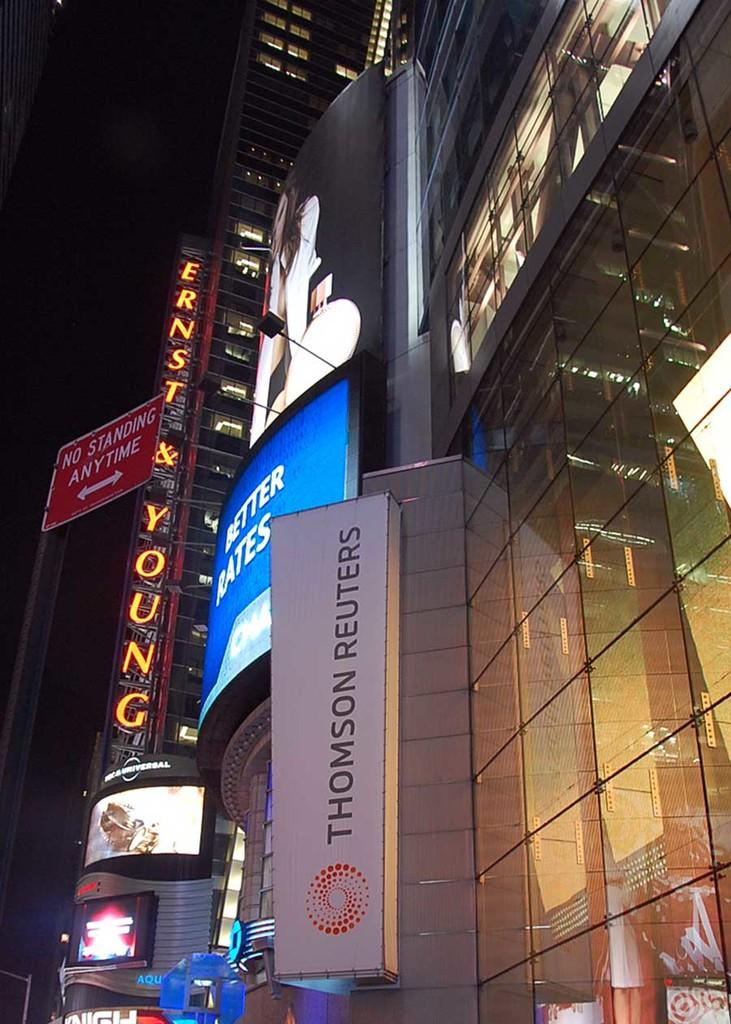What type of structures can be seen in the image? There are buildings in the image. What can be seen illuminating the scene in the image? There are lights in the image. What type of signage or information is present in the image? There are boards in the image. What is visible at the top of the image? The sky is visible at the top of the image. Where are the plants growing in the image? There are no plants visible in the image. What type of waves can be seen crashing on the shore in the image? There is no shore or waves present in the image. 